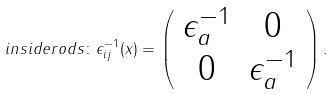<formula> <loc_0><loc_0><loc_500><loc_500>i n s i d e r o d s \colon \epsilon _ { i j } ^ { - 1 } ( x ) = \left ( \begin{array} { c c } \epsilon _ { a } ^ { - 1 } & 0 \\ 0 & \epsilon _ { a } ^ { - 1 } \end{array} \right ) .</formula> 